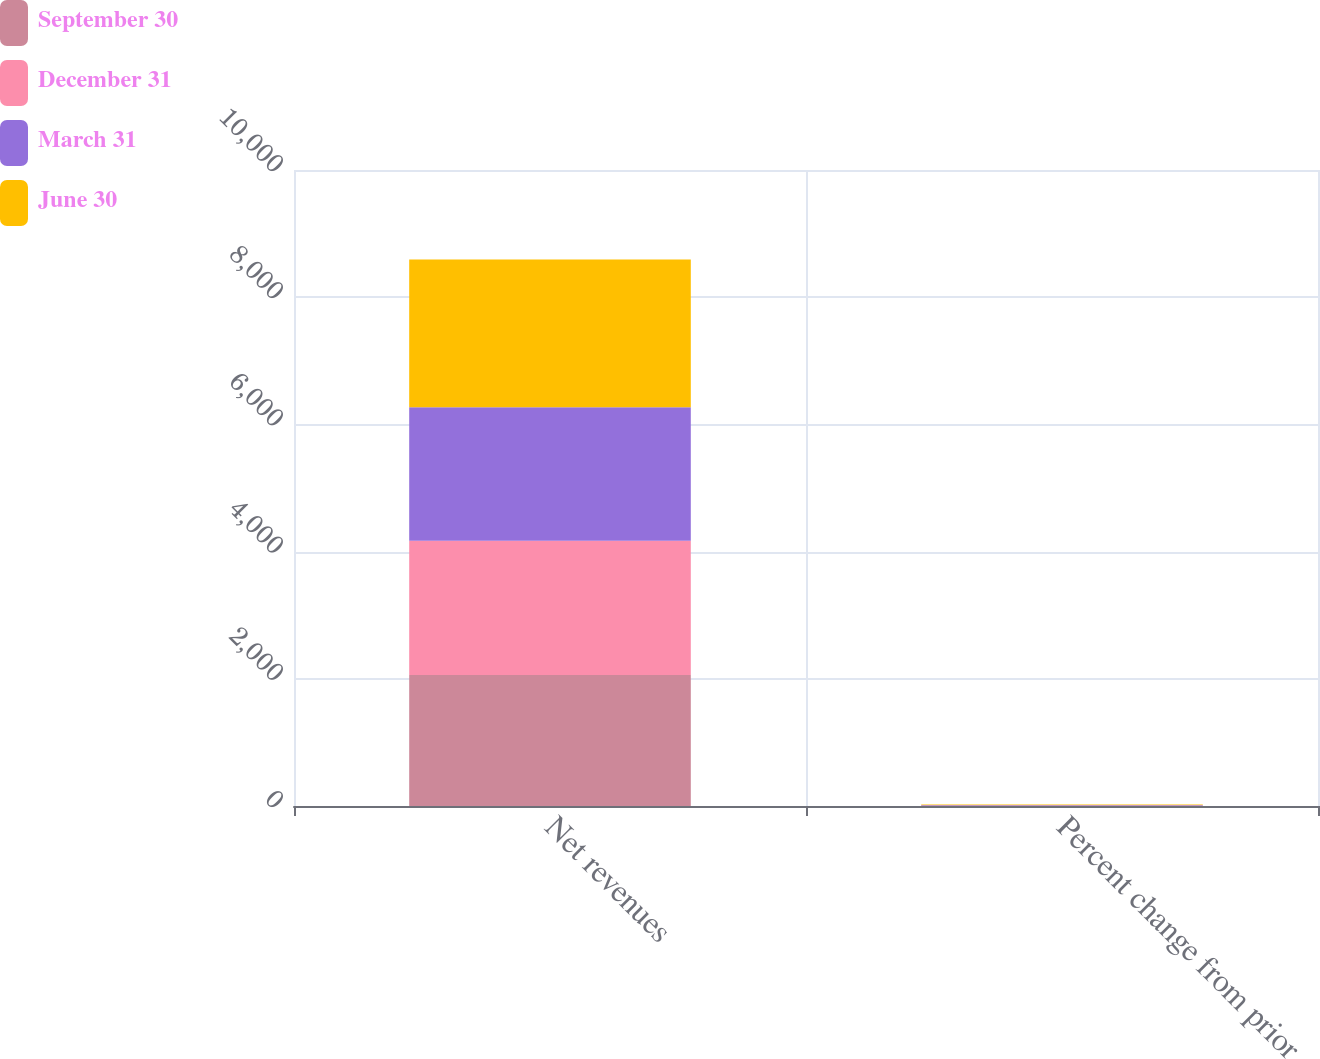Convert chart to OTSL. <chart><loc_0><loc_0><loc_500><loc_500><stacked_bar_chart><ecel><fcel>Net revenues<fcel>Percent change from prior<nl><fcel>September 30<fcel>2061<fcel>11<nl><fcel>December 31<fcel>2110<fcel>2<nl><fcel>March 31<fcel>2099<fcel>1<nl><fcel>June 30<fcel>2322<fcel>11<nl></chart> 